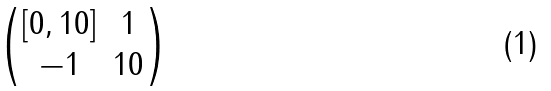Convert formula to latex. <formula><loc_0><loc_0><loc_500><loc_500>\begin{pmatrix} [ 0 , 1 0 ] & 1 \\ - 1 & 1 0 \end{pmatrix}</formula> 